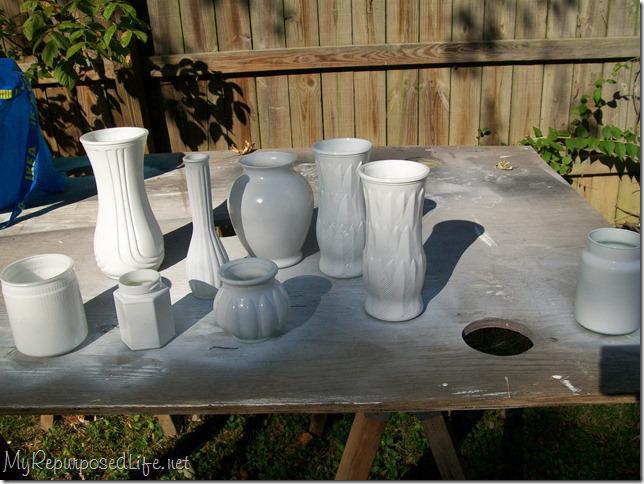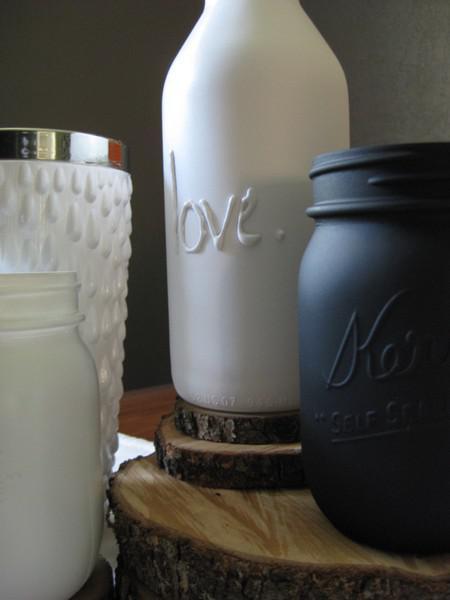The first image is the image on the left, the second image is the image on the right. For the images shown, is this caption "In one image, a display of milk glass shows a squat pumpkin-shaped piece in front of one shaped like an urn." true? Answer yes or no. Yes. 